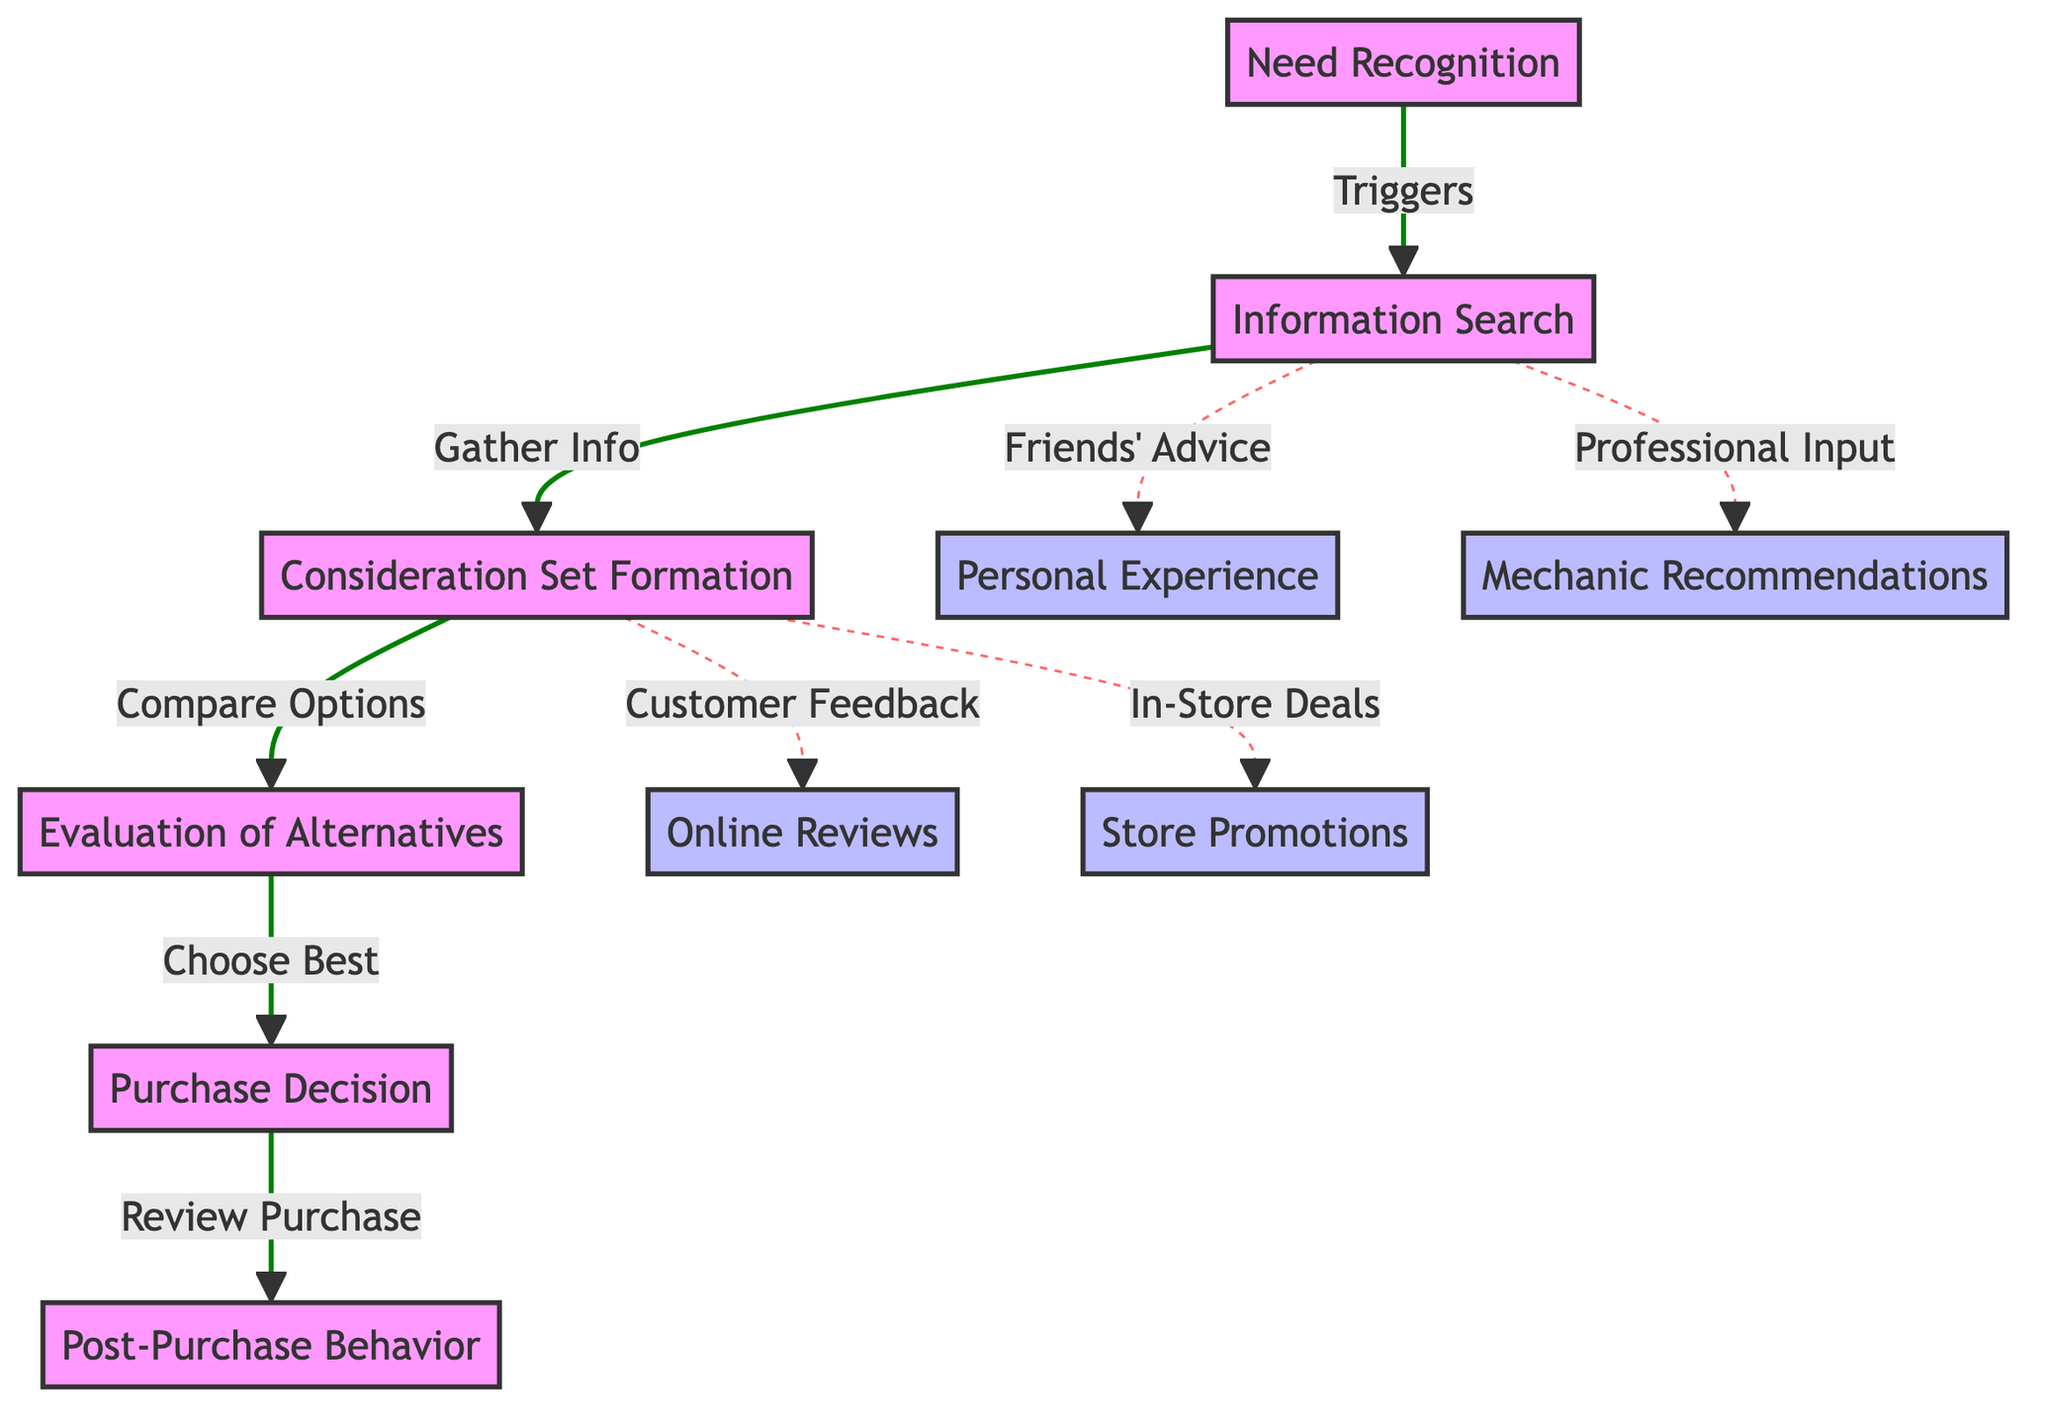What is the first step in the customer decision-making process? The first step listed in the diagram is "Need Recognition," indicating that the customer recognizes a need before engaging in further steps.
Answer: Need Recognition How many nodes are present in the diagram? By counting the numbered nodes in the flowchart, we find a total of ten nodes representing different stages and influences in the decision-making process.
Answer: Ten What action occurs after "Information Search"? According to the flowchart, after "Information Search," the customer moves on to "Consideration Set Formation," indicating the transition from gathering information to forming a set of options.
Answer: Consideration Set Formation Which two factors influence the "Information Search"? The diagram shows that both "Friends' Advice" and "Professional Input" influence the "Information Search," leading to alternative suggestions alongside personal research.
Answer: Friends' Advice and Professional Input What do customers do during "Evaluation of Alternatives"? The flowchart indicates that during this step, customers "Choose Best," reflecting the action of comparing their options and selecting the most suitable one for their needs.
Answer: Choose Best Which type of feedback is connected to "Consideration Set Formation"? The diagram indicates that "Customer Feedback" is linked to "Consideration Set Formation," showing that feedback from other customers affects the options considered by the customer.
Answer: Customer Feedback What is the relationship between "Purchase Decision" and "Post-Purchase Behavior"? The flowchart shows a direct sequential connection, where the "Purchase Decision" leads to "Post-Purchase Behavior," indicating that the decision impacts the customer’s reflections on their purchase.
Answer: Direct connection What color signifies secondary influences in the diagram? The color associated with secondary influences, such as "Personal Experience" and "Mechanic Recommendations," is light blue (bbf), highlighting their supportive role in the decision-making process.
Answer: Light blue Which element in the diagram represents promotional impacts? The "Store Promotions" box represents promotional impacts, showcasing how in-store deals can influence the consideration of options in the decision-making process.
Answer: Store Promotions How many dashed lines are present in the diagram? There are four dashed lines present, illustrating alternative paths that represent influences on the decision-making process, such as feedback and promotions that complement the primary flow.
Answer: Four 